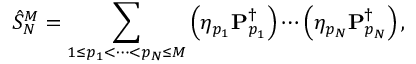<formula> <loc_0><loc_0><loc_500><loc_500>\hat { S } _ { N } ^ { M } = \sum _ { 1 \leq p _ { 1 } < \cdots < p _ { N } \leq M } \left ( \eta _ { p _ { 1 } } P _ { p _ { 1 } } ^ { \dagger } \right ) \cdots \left ( \eta _ { p _ { N } } P _ { p _ { N } } ^ { \dagger } \right ) ,</formula> 